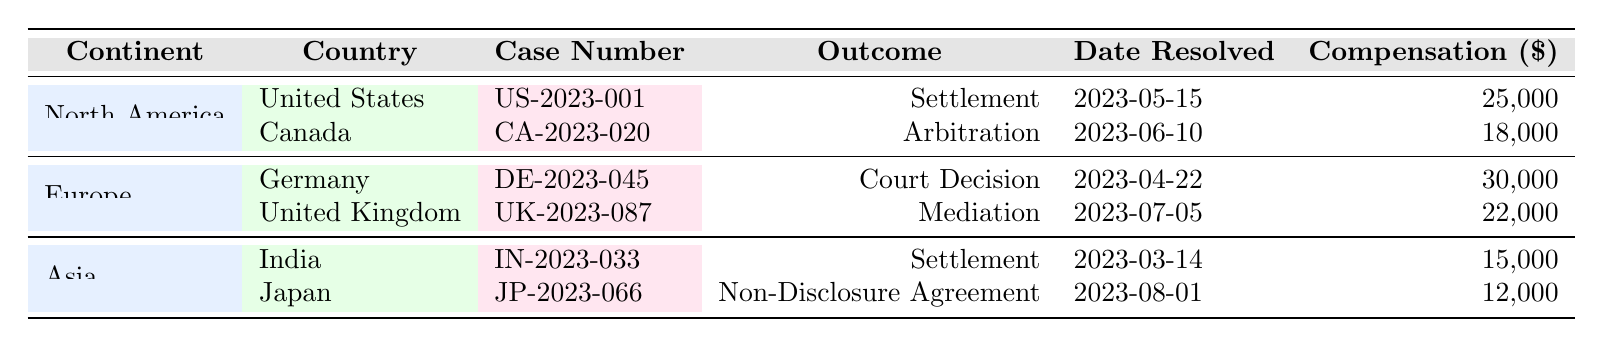What is the outcome of the dispute case from Canada? The table shows the row for Canada under North America. The case number for Canada is CA-2023-020, and the outcome listed is Arbitration.
Answer: Arbitration Which country has a higher compensation value, Germany or the United States? In the table, the compensation for the United States (US-2023-001) is 25,000, and for Germany (DE-2023-045) it is 30,000. Germany's compensation is higher.
Answer: Germany What was the date when the case in India was resolved? Referring to the row for India, the resolution date for the case IN-2023-033 is listed as 2023-03-14.
Answer: 2023-03-14 Is the outcome of the dispute cases in both Asia countries a mediation? The outcomes listed for Asia are Settlement for India and Non-Disclosure Agreement for Japan, which means that not both cases result in mediation.
Answer: No Calculate the total compensation awarded in North America. First, we list the compensation for North America: United States is 25,000 and Canada is 18,000. We add these together: 25,000 + 18,000 = 43,000. Thus, the total compensation in North America is 43,000.
Answer: 43,000 What kind of legal resolution was achieved in the United Kingdom? The table highlights that for the dispute case UK-2023-087, the outcome recorded is Mediation.
Answer: Mediation Was there a court decision in any of the cases listed under Europe? Looking at the Europe section, we see that the outcome for Germany (DE-2023-045) is a Court Decision. Therefore, the answer is yes, there was a court decision.
Answer: Yes What is the lowest compensation amount recorded in the table? By examining the compensation values: 25,000 (US), 18,000 (Canada), 30,000 (Germany), 22,000 (UK), 15,000 (India), and 12,000 (Japan). The minimum value is 12,000 from Japan.
Answer: 12,000 How many cases in total were resolved by a settlement? The table displays two cases with a settlement outcome: US-2023-001 (United States) and IN-2023-033 (India). Therefore, the total is two cases.
Answer: 2 